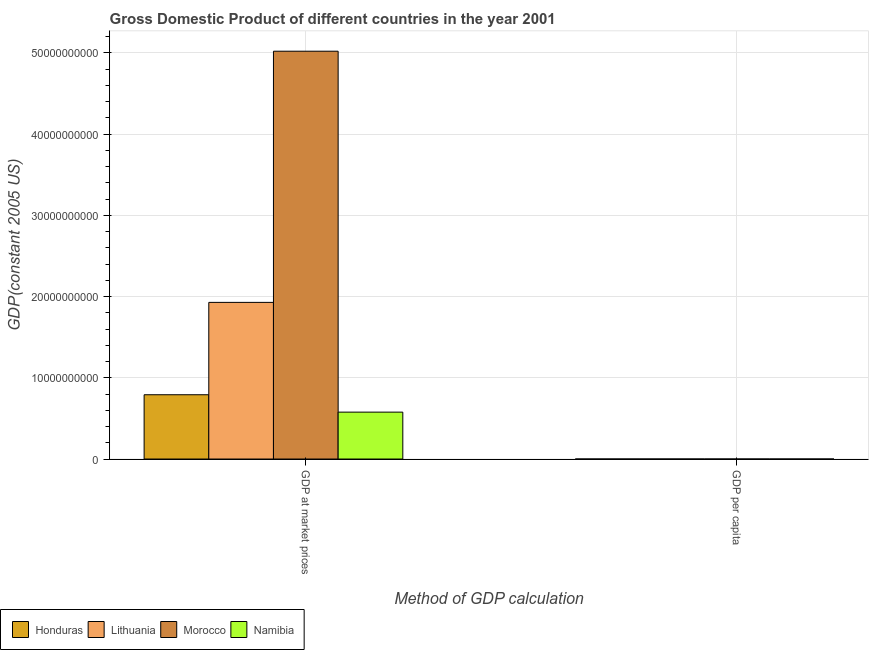How many different coloured bars are there?
Provide a short and direct response. 4. How many groups of bars are there?
Provide a succinct answer. 2. How many bars are there on the 2nd tick from the left?
Your answer should be compact. 4. What is the label of the 2nd group of bars from the left?
Offer a very short reply. GDP per capita. What is the gdp at market prices in Honduras?
Offer a terse response. 7.91e+09. Across all countries, what is the maximum gdp per capita?
Your answer should be compact. 5556.85. Across all countries, what is the minimum gdp at market prices?
Ensure brevity in your answer.  5.78e+09. In which country was the gdp per capita maximum?
Your answer should be compact. Lithuania. In which country was the gdp per capita minimum?
Make the answer very short. Honduras. What is the total gdp per capita in the graph?
Your answer should be very brief. 1.15e+04. What is the difference between the gdp per capita in Lithuania and that in Namibia?
Your answer should be compact. 2566.13. What is the difference between the gdp per capita in Honduras and the gdp at market prices in Morocco?
Provide a succinct answer. -5.02e+1. What is the average gdp at market prices per country?
Make the answer very short. 2.08e+1. What is the difference between the gdp per capita and gdp at market prices in Lithuania?
Ensure brevity in your answer.  -1.93e+1. What is the ratio of the gdp per capita in Namibia to that in Honduras?
Offer a terse response. 2.41. What does the 4th bar from the left in GDP per capita represents?
Ensure brevity in your answer.  Namibia. What does the 3rd bar from the right in GDP per capita represents?
Provide a succinct answer. Lithuania. How many bars are there?
Offer a very short reply. 8. What is the difference between two consecutive major ticks on the Y-axis?
Provide a short and direct response. 1.00e+1. Are the values on the major ticks of Y-axis written in scientific E-notation?
Give a very brief answer. No. Does the graph contain any zero values?
Make the answer very short. No. Where does the legend appear in the graph?
Provide a short and direct response. Bottom left. How many legend labels are there?
Your answer should be compact. 4. How are the legend labels stacked?
Offer a terse response. Horizontal. What is the title of the graph?
Provide a succinct answer. Gross Domestic Product of different countries in the year 2001. What is the label or title of the X-axis?
Provide a succinct answer. Method of GDP calculation. What is the label or title of the Y-axis?
Offer a terse response. GDP(constant 2005 US). What is the GDP(constant 2005 US) of Honduras in GDP at market prices?
Your answer should be very brief. 7.91e+09. What is the GDP(constant 2005 US) of Lithuania in GDP at market prices?
Ensure brevity in your answer.  1.93e+1. What is the GDP(constant 2005 US) of Morocco in GDP at market prices?
Provide a short and direct response. 5.02e+1. What is the GDP(constant 2005 US) of Namibia in GDP at market prices?
Make the answer very short. 5.78e+09. What is the GDP(constant 2005 US) in Honduras in GDP per capita?
Provide a succinct answer. 1242.23. What is the GDP(constant 2005 US) in Lithuania in GDP per capita?
Keep it short and to the point. 5556.85. What is the GDP(constant 2005 US) in Morocco in GDP per capita?
Give a very brief answer. 1697.64. What is the GDP(constant 2005 US) of Namibia in GDP per capita?
Your answer should be very brief. 2990.72. Across all Method of GDP calculation, what is the maximum GDP(constant 2005 US) of Honduras?
Make the answer very short. 7.91e+09. Across all Method of GDP calculation, what is the maximum GDP(constant 2005 US) in Lithuania?
Your answer should be compact. 1.93e+1. Across all Method of GDP calculation, what is the maximum GDP(constant 2005 US) in Morocco?
Keep it short and to the point. 5.02e+1. Across all Method of GDP calculation, what is the maximum GDP(constant 2005 US) in Namibia?
Give a very brief answer. 5.78e+09. Across all Method of GDP calculation, what is the minimum GDP(constant 2005 US) of Honduras?
Keep it short and to the point. 1242.23. Across all Method of GDP calculation, what is the minimum GDP(constant 2005 US) in Lithuania?
Make the answer very short. 5556.85. Across all Method of GDP calculation, what is the minimum GDP(constant 2005 US) of Morocco?
Your response must be concise. 1697.64. Across all Method of GDP calculation, what is the minimum GDP(constant 2005 US) in Namibia?
Your answer should be compact. 2990.72. What is the total GDP(constant 2005 US) of Honduras in the graph?
Give a very brief answer. 7.91e+09. What is the total GDP(constant 2005 US) of Lithuania in the graph?
Your answer should be compact. 1.93e+1. What is the total GDP(constant 2005 US) of Morocco in the graph?
Provide a short and direct response. 5.02e+1. What is the total GDP(constant 2005 US) in Namibia in the graph?
Give a very brief answer. 5.78e+09. What is the difference between the GDP(constant 2005 US) in Honduras in GDP at market prices and that in GDP per capita?
Offer a terse response. 7.91e+09. What is the difference between the GDP(constant 2005 US) in Lithuania in GDP at market prices and that in GDP per capita?
Offer a terse response. 1.93e+1. What is the difference between the GDP(constant 2005 US) in Morocco in GDP at market prices and that in GDP per capita?
Keep it short and to the point. 5.02e+1. What is the difference between the GDP(constant 2005 US) in Namibia in GDP at market prices and that in GDP per capita?
Provide a succinct answer. 5.78e+09. What is the difference between the GDP(constant 2005 US) of Honduras in GDP at market prices and the GDP(constant 2005 US) of Lithuania in GDP per capita?
Give a very brief answer. 7.91e+09. What is the difference between the GDP(constant 2005 US) of Honduras in GDP at market prices and the GDP(constant 2005 US) of Morocco in GDP per capita?
Offer a terse response. 7.91e+09. What is the difference between the GDP(constant 2005 US) in Honduras in GDP at market prices and the GDP(constant 2005 US) in Namibia in GDP per capita?
Your answer should be very brief. 7.91e+09. What is the difference between the GDP(constant 2005 US) in Lithuania in GDP at market prices and the GDP(constant 2005 US) in Morocco in GDP per capita?
Your response must be concise. 1.93e+1. What is the difference between the GDP(constant 2005 US) of Lithuania in GDP at market prices and the GDP(constant 2005 US) of Namibia in GDP per capita?
Your answer should be very brief. 1.93e+1. What is the difference between the GDP(constant 2005 US) in Morocco in GDP at market prices and the GDP(constant 2005 US) in Namibia in GDP per capita?
Offer a very short reply. 5.02e+1. What is the average GDP(constant 2005 US) of Honduras per Method of GDP calculation?
Give a very brief answer. 3.96e+09. What is the average GDP(constant 2005 US) in Lithuania per Method of GDP calculation?
Provide a succinct answer. 9.64e+09. What is the average GDP(constant 2005 US) in Morocco per Method of GDP calculation?
Keep it short and to the point. 2.51e+1. What is the average GDP(constant 2005 US) in Namibia per Method of GDP calculation?
Give a very brief answer. 2.89e+09. What is the difference between the GDP(constant 2005 US) of Honduras and GDP(constant 2005 US) of Lithuania in GDP at market prices?
Give a very brief answer. -1.14e+1. What is the difference between the GDP(constant 2005 US) in Honduras and GDP(constant 2005 US) in Morocco in GDP at market prices?
Make the answer very short. -4.23e+1. What is the difference between the GDP(constant 2005 US) in Honduras and GDP(constant 2005 US) in Namibia in GDP at market prices?
Provide a succinct answer. 2.14e+09. What is the difference between the GDP(constant 2005 US) in Lithuania and GDP(constant 2005 US) in Morocco in GDP at market prices?
Ensure brevity in your answer.  -3.09e+1. What is the difference between the GDP(constant 2005 US) of Lithuania and GDP(constant 2005 US) of Namibia in GDP at market prices?
Give a very brief answer. 1.35e+1. What is the difference between the GDP(constant 2005 US) in Morocco and GDP(constant 2005 US) in Namibia in GDP at market prices?
Offer a very short reply. 4.44e+1. What is the difference between the GDP(constant 2005 US) in Honduras and GDP(constant 2005 US) in Lithuania in GDP per capita?
Provide a succinct answer. -4314.62. What is the difference between the GDP(constant 2005 US) in Honduras and GDP(constant 2005 US) in Morocco in GDP per capita?
Your response must be concise. -455.41. What is the difference between the GDP(constant 2005 US) in Honduras and GDP(constant 2005 US) in Namibia in GDP per capita?
Your answer should be very brief. -1748.49. What is the difference between the GDP(constant 2005 US) in Lithuania and GDP(constant 2005 US) in Morocco in GDP per capita?
Your answer should be compact. 3859.21. What is the difference between the GDP(constant 2005 US) of Lithuania and GDP(constant 2005 US) of Namibia in GDP per capita?
Provide a succinct answer. 2566.13. What is the difference between the GDP(constant 2005 US) in Morocco and GDP(constant 2005 US) in Namibia in GDP per capita?
Provide a short and direct response. -1293.07. What is the ratio of the GDP(constant 2005 US) in Honduras in GDP at market prices to that in GDP per capita?
Your answer should be compact. 6.37e+06. What is the ratio of the GDP(constant 2005 US) in Lithuania in GDP at market prices to that in GDP per capita?
Provide a succinct answer. 3.47e+06. What is the ratio of the GDP(constant 2005 US) in Morocco in GDP at market prices to that in GDP per capita?
Keep it short and to the point. 2.96e+07. What is the ratio of the GDP(constant 2005 US) of Namibia in GDP at market prices to that in GDP per capita?
Your response must be concise. 1.93e+06. What is the difference between the highest and the second highest GDP(constant 2005 US) of Honduras?
Make the answer very short. 7.91e+09. What is the difference between the highest and the second highest GDP(constant 2005 US) in Lithuania?
Your answer should be very brief. 1.93e+1. What is the difference between the highest and the second highest GDP(constant 2005 US) in Morocco?
Make the answer very short. 5.02e+1. What is the difference between the highest and the second highest GDP(constant 2005 US) of Namibia?
Offer a terse response. 5.78e+09. What is the difference between the highest and the lowest GDP(constant 2005 US) of Honduras?
Your response must be concise. 7.91e+09. What is the difference between the highest and the lowest GDP(constant 2005 US) in Lithuania?
Ensure brevity in your answer.  1.93e+1. What is the difference between the highest and the lowest GDP(constant 2005 US) in Morocco?
Ensure brevity in your answer.  5.02e+1. What is the difference between the highest and the lowest GDP(constant 2005 US) in Namibia?
Provide a short and direct response. 5.78e+09. 